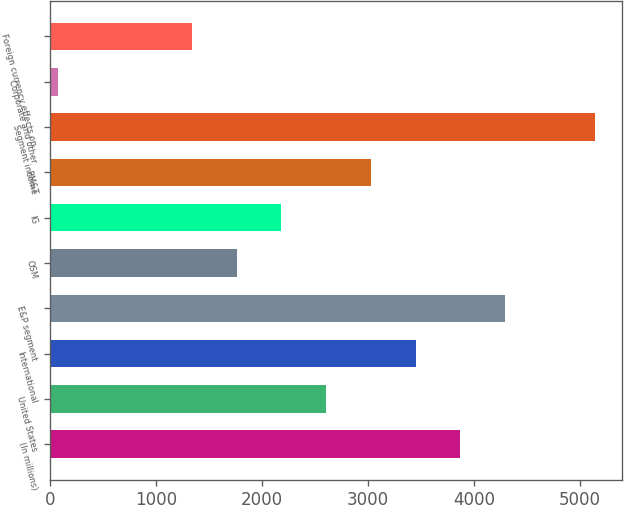Convert chart to OTSL. <chart><loc_0><loc_0><loc_500><loc_500><bar_chart><fcel>(In millions)<fcel>United States<fcel>International<fcel>E&P segment<fcel>OSM<fcel>IG<fcel>RM&T<fcel>Segment income<fcel>Corporate and other<fcel>Foreign currency effects on<nl><fcel>3873<fcel>2607<fcel>3451<fcel>4295<fcel>1763<fcel>2185<fcel>3029<fcel>5139<fcel>75<fcel>1341<nl></chart> 